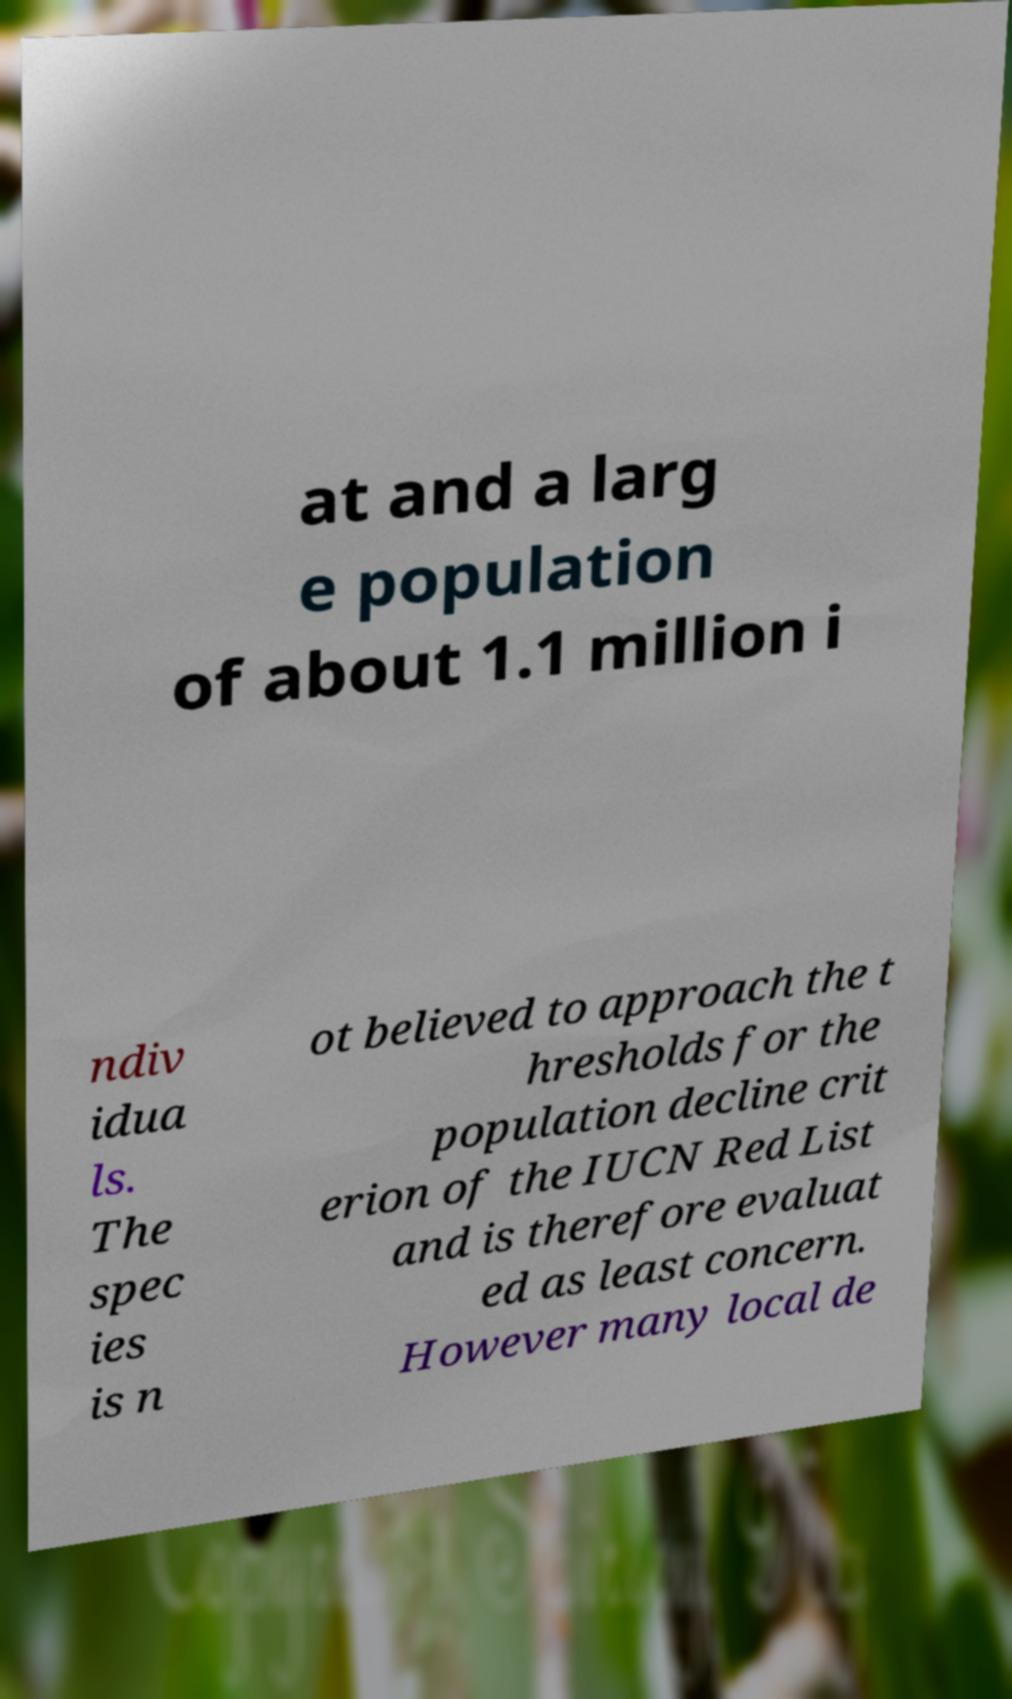Can you read and provide the text displayed in the image?This photo seems to have some interesting text. Can you extract and type it out for me? at and a larg e population of about 1.1 million i ndiv idua ls. The spec ies is n ot believed to approach the t hresholds for the population decline crit erion of the IUCN Red List and is therefore evaluat ed as least concern. However many local de 